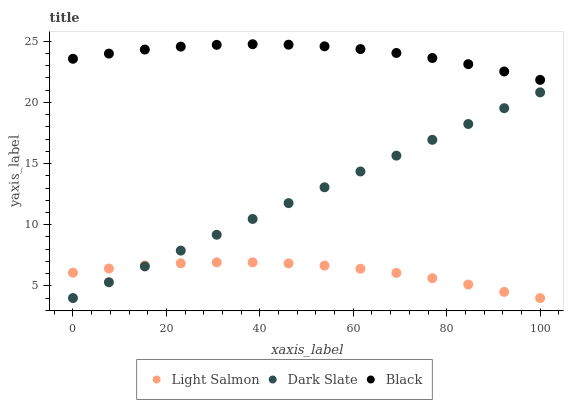Does Light Salmon have the minimum area under the curve?
Answer yes or no. Yes. Does Black have the maximum area under the curve?
Answer yes or no. Yes. Does Black have the minimum area under the curve?
Answer yes or no. No. Does Light Salmon have the maximum area under the curve?
Answer yes or no. No. Is Dark Slate the smoothest?
Answer yes or no. Yes. Is Black the roughest?
Answer yes or no. Yes. Is Light Salmon the smoothest?
Answer yes or no. No. Is Light Salmon the roughest?
Answer yes or no. No. Does Dark Slate have the lowest value?
Answer yes or no. Yes. Does Black have the lowest value?
Answer yes or no. No. Does Black have the highest value?
Answer yes or no. Yes. Does Light Salmon have the highest value?
Answer yes or no. No. Is Light Salmon less than Black?
Answer yes or no. Yes. Is Black greater than Light Salmon?
Answer yes or no. Yes. Does Light Salmon intersect Dark Slate?
Answer yes or no. Yes. Is Light Salmon less than Dark Slate?
Answer yes or no. No. Is Light Salmon greater than Dark Slate?
Answer yes or no. No. Does Light Salmon intersect Black?
Answer yes or no. No. 